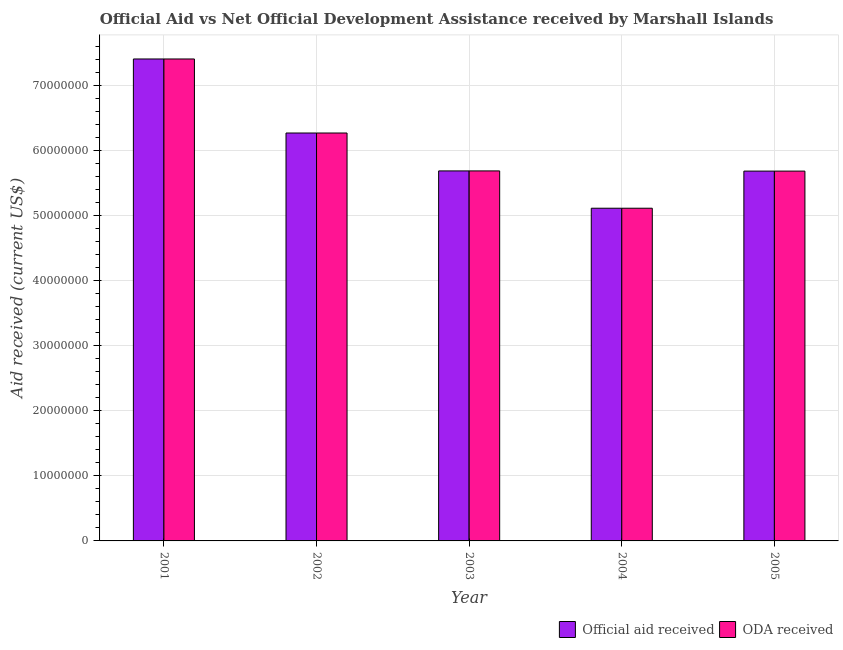How many different coloured bars are there?
Offer a very short reply. 2. How many groups of bars are there?
Make the answer very short. 5. Are the number of bars on each tick of the X-axis equal?
Make the answer very short. Yes. How many bars are there on the 5th tick from the left?
Ensure brevity in your answer.  2. How many bars are there on the 4th tick from the right?
Your answer should be compact. 2. What is the label of the 4th group of bars from the left?
Your answer should be very brief. 2004. In how many cases, is the number of bars for a given year not equal to the number of legend labels?
Your answer should be compact. 0. What is the oda received in 2005?
Give a very brief answer. 5.68e+07. Across all years, what is the maximum oda received?
Your answer should be very brief. 7.40e+07. Across all years, what is the minimum official aid received?
Ensure brevity in your answer.  5.11e+07. What is the total official aid received in the graph?
Ensure brevity in your answer.  3.01e+08. What is the difference between the oda received in 2002 and that in 2003?
Keep it short and to the point. 5.82e+06. What is the difference between the oda received in 2003 and the official aid received in 2005?
Provide a short and direct response. 3.00e+04. What is the average oda received per year?
Keep it short and to the point. 6.03e+07. In the year 2004, what is the difference between the official aid received and oda received?
Give a very brief answer. 0. In how many years, is the oda received greater than 46000000 US$?
Your answer should be compact. 5. What is the ratio of the oda received in 2001 to that in 2003?
Your answer should be very brief. 1.3. Is the difference between the official aid received in 2001 and 2003 greater than the difference between the oda received in 2001 and 2003?
Make the answer very short. No. What is the difference between the highest and the second highest official aid received?
Provide a succinct answer. 1.14e+07. What is the difference between the highest and the lowest oda received?
Provide a short and direct response. 2.29e+07. In how many years, is the oda received greater than the average oda received taken over all years?
Provide a short and direct response. 2. What does the 1st bar from the left in 2001 represents?
Provide a succinct answer. Official aid received. What does the 2nd bar from the right in 2001 represents?
Make the answer very short. Official aid received. Are all the bars in the graph horizontal?
Make the answer very short. No. How many years are there in the graph?
Your response must be concise. 5. Are the values on the major ticks of Y-axis written in scientific E-notation?
Your response must be concise. No. Does the graph contain any zero values?
Keep it short and to the point. No. How many legend labels are there?
Your answer should be compact. 2. How are the legend labels stacked?
Your response must be concise. Horizontal. What is the title of the graph?
Your answer should be very brief. Official Aid vs Net Official Development Assistance received by Marshall Islands . What is the label or title of the X-axis?
Provide a succinct answer. Year. What is the label or title of the Y-axis?
Give a very brief answer. Aid received (current US$). What is the Aid received (current US$) in Official aid received in 2001?
Provide a short and direct response. 7.40e+07. What is the Aid received (current US$) of ODA received in 2001?
Offer a terse response. 7.40e+07. What is the Aid received (current US$) in Official aid received in 2002?
Make the answer very short. 6.26e+07. What is the Aid received (current US$) in ODA received in 2002?
Make the answer very short. 6.26e+07. What is the Aid received (current US$) of Official aid received in 2003?
Ensure brevity in your answer.  5.68e+07. What is the Aid received (current US$) in ODA received in 2003?
Make the answer very short. 5.68e+07. What is the Aid received (current US$) in Official aid received in 2004?
Provide a succinct answer. 5.11e+07. What is the Aid received (current US$) in ODA received in 2004?
Keep it short and to the point. 5.11e+07. What is the Aid received (current US$) in Official aid received in 2005?
Your answer should be very brief. 5.68e+07. What is the Aid received (current US$) in ODA received in 2005?
Make the answer very short. 5.68e+07. Across all years, what is the maximum Aid received (current US$) of Official aid received?
Ensure brevity in your answer.  7.40e+07. Across all years, what is the maximum Aid received (current US$) of ODA received?
Your answer should be compact. 7.40e+07. Across all years, what is the minimum Aid received (current US$) in Official aid received?
Offer a terse response. 5.11e+07. Across all years, what is the minimum Aid received (current US$) of ODA received?
Your answer should be compact. 5.11e+07. What is the total Aid received (current US$) of Official aid received in the graph?
Provide a short and direct response. 3.01e+08. What is the total Aid received (current US$) of ODA received in the graph?
Your answer should be very brief. 3.01e+08. What is the difference between the Aid received (current US$) of Official aid received in 2001 and that in 2002?
Your answer should be compact. 1.14e+07. What is the difference between the Aid received (current US$) in ODA received in 2001 and that in 2002?
Keep it short and to the point. 1.14e+07. What is the difference between the Aid received (current US$) in Official aid received in 2001 and that in 2003?
Provide a succinct answer. 1.72e+07. What is the difference between the Aid received (current US$) in ODA received in 2001 and that in 2003?
Offer a very short reply. 1.72e+07. What is the difference between the Aid received (current US$) in Official aid received in 2001 and that in 2004?
Provide a succinct answer. 2.29e+07. What is the difference between the Aid received (current US$) of ODA received in 2001 and that in 2004?
Your answer should be very brief. 2.29e+07. What is the difference between the Aid received (current US$) in Official aid received in 2001 and that in 2005?
Give a very brief answer. 1.72e+07. What is the difference between the Aid received (current US$) of ODA received in 2001 and that in 2005?
Keep it short and to the point. 1.72e+07. What is the difference between the Aid received (current US$) in Official aid received in 2002 and that in 2003?
Provide a short and direct response. 5.82e+06. What is the difference between the Aid received (current US$) in ODA received in 2002 and that in 2003?
Ensure brevity in your answer.  5.82e+06. What is the difference between the Aid received (current US$) in Official aid received in 2002 and that in 2004?
Keep it short and to the point. 1.16e+07. What is the difference between the Aid received (current US$) of ODA received in 2002 and that in 2004?
Your response must be concise. 1.16e+07. What is the difference between the Aid received (current US$) in Official aid received in 2002 and that in 2005?
Keep it short and to the point. 5.85e+06. What is the difference between the Aid received (current US$) of ODA received in 2002 and that in 2005?
Provide a succinct answer. 5.85e+06. What is the difference between the Aid received (current US$) in Official aid received in 2003 and that in 2004?
Your response must be concise. 5.73e+06. What is the difference between the Aid received (current US$) in ODA received in 2003 and that in 2004?
Offer a terse response. 5.73e+06. What is the difference between the Aid received (current US$) of Official aid received in 2004 and that in 2005?
Your answer should be very brief. -5.70e+06. What is the difference between the Aid received (current US$) in ODA received in 2004 and that in 2005?
Your answer should be compact. -5.70e+06. What is the difference between the Aid received (current US$) of Official aid received in 2001 and the Aid received (current US$) of ODA received in 2002?
Provide a short and direct response. 1.14e+07. What is the difference between the Aid received (current US$) in Official aid received in 2001 and the Aid received (current US$) in ODA received in 2003?
Offer a very short reply. 1.72e+07. What is the difference between the Aid received (current US$) in Official aid received in 2001 and the Aid received (current US$) in ODA received in 2004?
Your answer should be very brief. 2.29e+07. What is the difference between the Aid received (current US$) of Official aid received in 2001 and the Aid received (current US$) of ODA received in 2005?
Your answer should be compact. 1.72e+07. What is the difference between the Aid received (current US$) in Official aid received in 2002 and the Aid received (current US$) in ODA received in 2003?
Your answer should be very brief. 5.82e+06. What is the difference between the Aid received (current US$) in Official aid received in 2002 and the Aid received (current US$) in ODA received in 2004?
Keep it short and to the point. 1.16e+07. What is the difference between the Aid received (current US$) in Official aid received in 2002 and the Aid received (current US$) in ODA received in 2005?
Provide a succinct answer. 5.85e+06. What is the difference between the Aid received (current US$) of Official aid received in 2003 and the Aid received (current US$) of ODA received in 2004?
Provide a succinct answer. 5.73e+06. What is the difference between the Aid received (current US$) of Official aid received in 2004 and the Aid received (current US$) of ODA received in 2005?
Your response must be concise. -5.70e+06. What is the average Aid received (current US$) in Official aid received per year?
Keep it short and to the point. 6.03e+07. What is the average Aid received (current US$) in ODA received per year?
Provide a succinct answer. 6.03e+07. In the year 2002, what is the difference between the Aid received (current US$) of Official aid received and Aid received (current US$) of ODA received?
Your answer should be compact. 0. In the year 2003, what is the difference between the Aid received (current US$) of Official aid received and Aid received (current US$) of ODA received?
Offer a terse response. 0. What is the ratio of the Aid received (current US$) of Official aid received in 2001 to that in 2002?
Provide a succinct answer. 1.18. What is the ratio of the Aid received (current US$) in ODA received in 2001 to that in 2002?
Keep it short and to the point. 1.18. What is the ratio of the Aid received (current US$) in Official aid received in 2001 to that in 2003?
Provide a short and direct response. 1.3. What is the ratio of the Aid received (current US$) of ODA received in 2001 to that in 2003?
Provide a short and direct response. 1.3. What is the ratio of the Aid received (current US$) of Official aid received in 2001 to that in 2004?
Ensure brevity in your answer.  1.45. What is the ratio of the Aid received (current US$) in ODA received in 2001 to that in 2004?
Your answer should be compact. 1.45. What is the ratio of the Aid received (current US$) in Official aid received in 2001 to that in 2005?
Offer a terse response. 1.3. What is the ratio of the Aid received (current US$) in ODA received in 2001 to that in 2005?
Keep it short and to the point. 1.3. What is the ratio of the Aid received (current US$) in Official aid received in 2002 to that in 2003?
Offer a very short reply. 1.1. What is the ratio of the Aid received (current US$) of ODA received in 2002 to that in 2003?
Keep it short and to the point. 1.1. What is the ratio of the Aid received (current US$) in Official aid received in 2002 to that in 2004?
Provide a succinct answer. 1.23. What is the ratio of the Aid received (current US$) of ODA received in 2002 to that in 2004?
Ensure brevity in your answer.  1.23. What is the ratio of the Aid received (current US$) in Official aid received in 2002 to that in 2005?
Your answer should be compact. 1.1. What is the ratio of the Aid received (current US$) in ODA received in 2002 to that in 2005?
Ensure brevity in your answer.  1.1. What is the ratio of the Aid received (current US$) in Official aid received in 2003 to that in 2004?
Your answer should be compact. 1.11. What is the ratio of the Aid received (current US$) of ODA received in 2003 to that in 2004?
Your answer should be very brief. 1.11. What is the ratio of the Aid received (current US$) of Official aid received in 2003 to that in 2005?
Ensure brevity in your answer.  1. What is the ratio of the Aid received (current US$) in ODA received in 2003 to that in 2005?
Provide a short and direct response. 1. What is the ratio of the Aid received (current US$) of Official aid received in 2004 to that in 2005?
Make the answer very short. 0.9. What is the ratio of the Aid received (current US$) of ODA received in 2004 to that in 2005?
Ensure brevity in your answer.  0.9. What is the difference between the highest and the second highest Aid received (current US$) in Official aid received?
Your response must be concise. 1.14e+07. What is the difference between the highest and the second highest Aid received (current US$) in ODA received?
Keep it short and to the point. 1.14e+07. What is the difference between the highest and the lowest Aid received (current US$) of Official aid received?
Keep it short and to the point. 2.29e+07. What is the difference between the highest and the lowest Aid received (current US$) in ODA received?
Ensure brevity in your answer.  2.29e+07. 